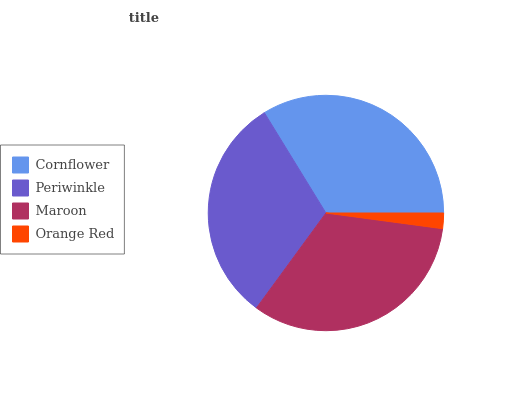Is Orange Red the minimum?
Answer yes or no. Yes. Is Cornflower the maximum?
Answer yes or no. Yes. Is Periwinkle the minimum?
Answer yes or no. No. Is Periwinkle the maximum?
Answer yes or no. No. Is Cornflower greater than Periwinkle?
Answer yes or no. Yes. Is Periwinkle less than Cornflower?
Answer yes or no. Yes. Is Periwinkle greater than Cornflower?
Answer yes or no. No. Is Cornflower less than Periwinkle?
Answer yes or no. No. Is Maroon the high median?
Answer yes or no. Yes. Is Periwinkle the low median?
Answer yes or no. Yes. Is Orange Red the high median?
Answer yes or no. No. Is Orange Red the low median?
Answer yes or no. No. 